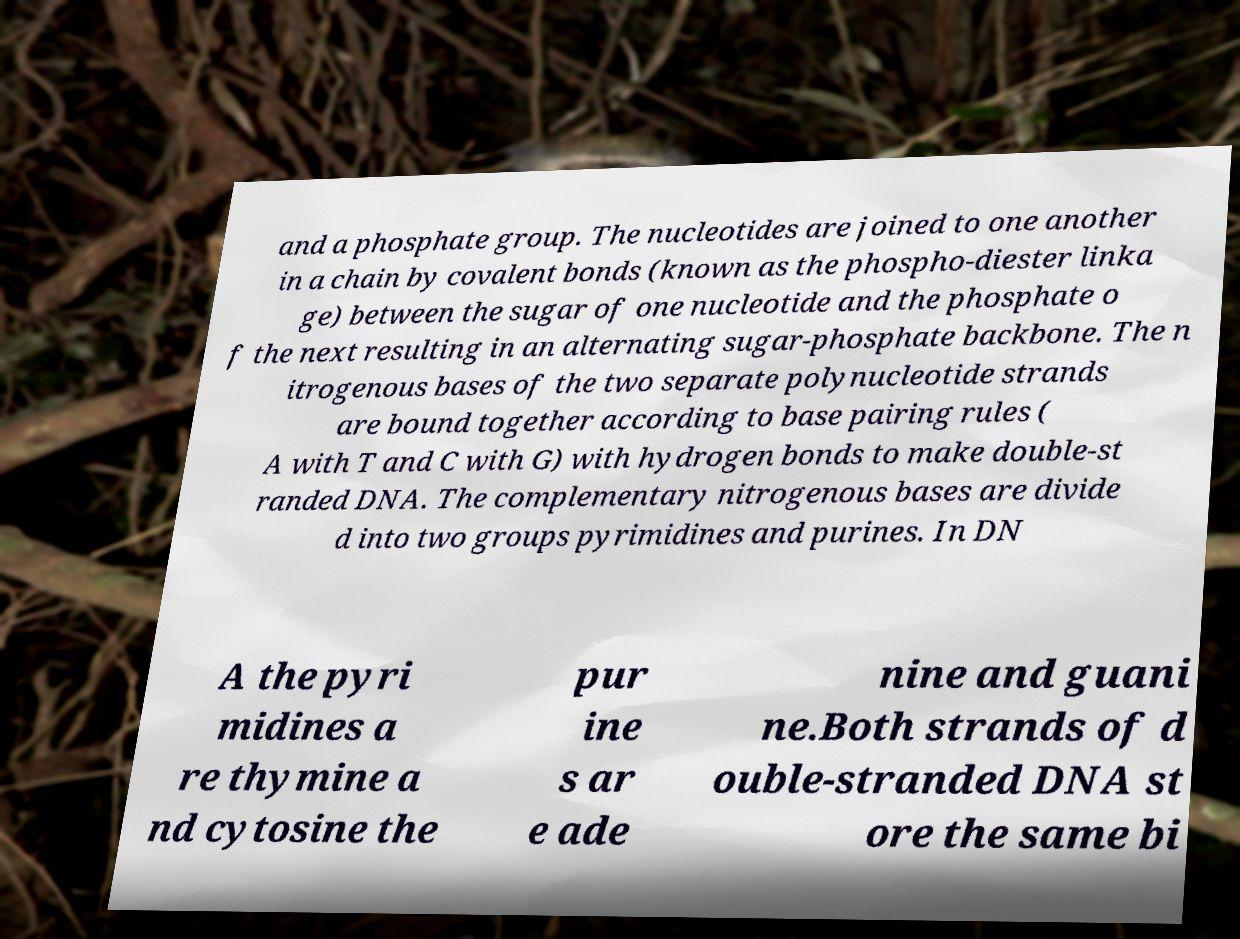Please read and relay the text visible in this image. What does it say? and a phosphate group. The nucleotides are joined to one another in a chain by covalent bonds (known as the phospho-diester linka ge) between the sugar of one nucleotide and the phosphate o f the next resulting in an alternating sugar-phosphate backbone. The n itrogenous bases of the two separate polynucleotide strands are bound together according to base pairing rules ( A with T and C with G) with hydrogen bonds to make double-st randed DNA. The complementary nitrogenous bases are divide d into two groups pyrimidines and purines. In DN A the pyri midines a re thymine a nd cytosine the pur ine s ar e ade nine and guani ne.Both strands of d ouble-stranded DNA st ore the same bi 